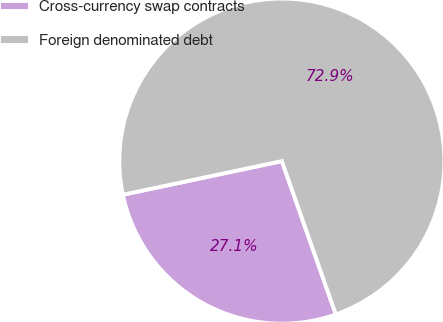Convert chart to OTSL. <chart><loc_0><loc_0><loc_500><loc_500><pie_chart><fcel>Cross-currency swap contracts<fcel>Foreign denominated debt<nl><fcel>27.07%<fcel>72.93%<nl></chart> 